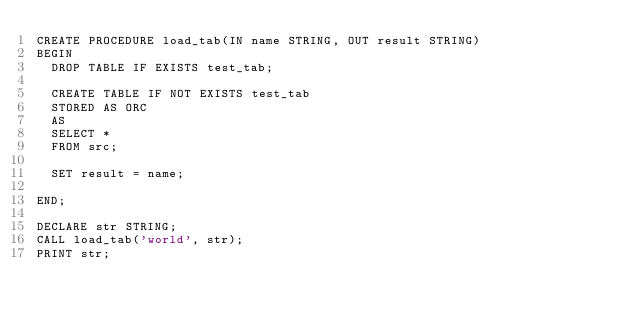Convert code to text. <code><loc_0><loc_0><loc_500><loc_500><_SQL_>CREATE PROCEDURE load_tab(IN name STRING, OUT result STRING)
BEGIN
  DROP TABLE IF EXISTS test_tab;

  CREATE TABLE IF NOT EXISTS test_tab
  STORED AS ORC
  AS
  SELECT *
  FROM src;

  SET result = name;

END;

DECLARE str STRING;
CALL load_tab('world', str);
PRINT str; </code> 